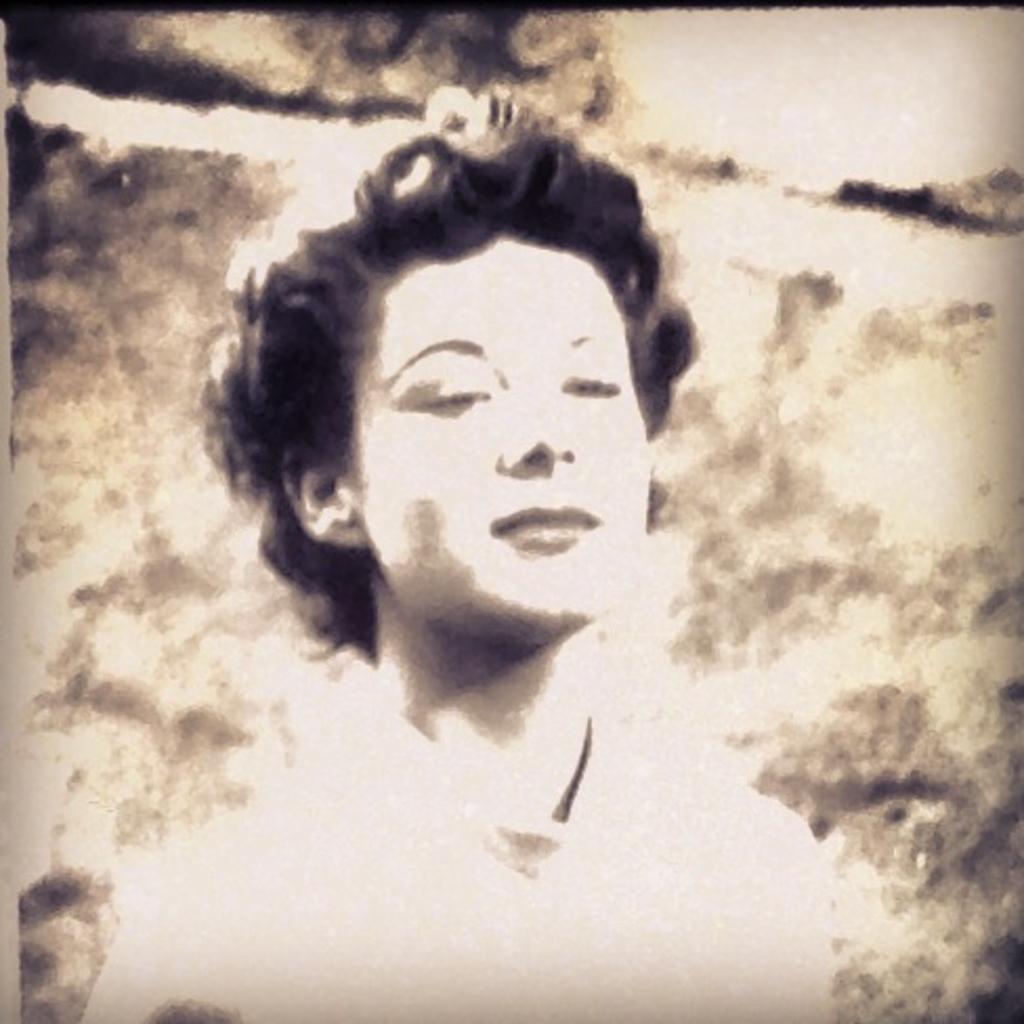In one or two sentences, can you explain what this image depicts? This is a monochrome image of a lady. 